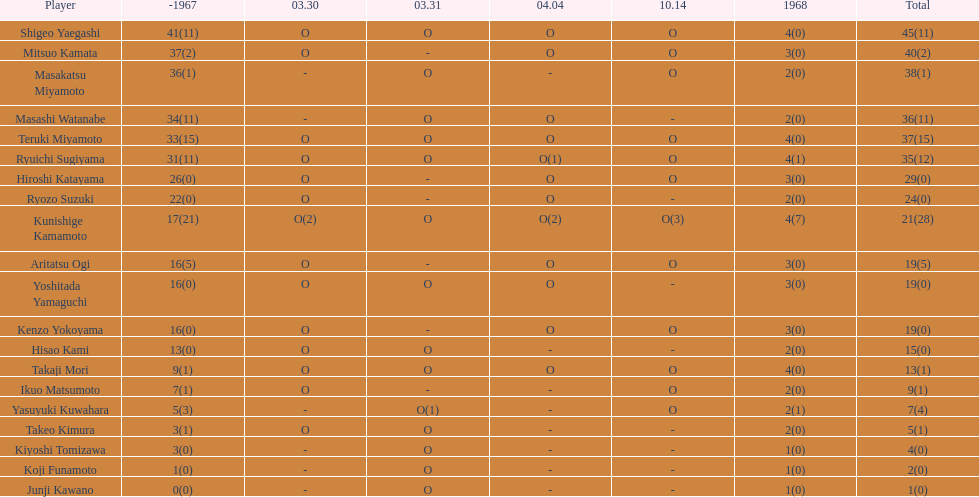What is the total number of appearances for masakatsu miyamoto? 38. 